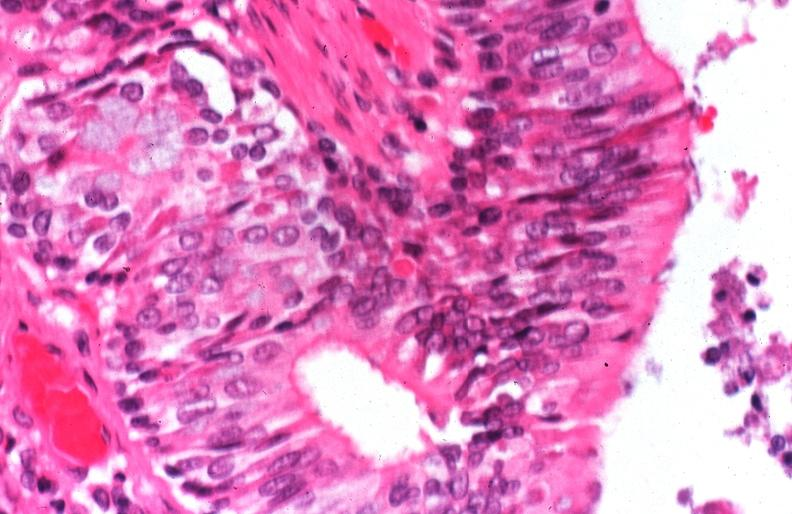what is present?
Answer the question using a single word or phrase. Respiratory 